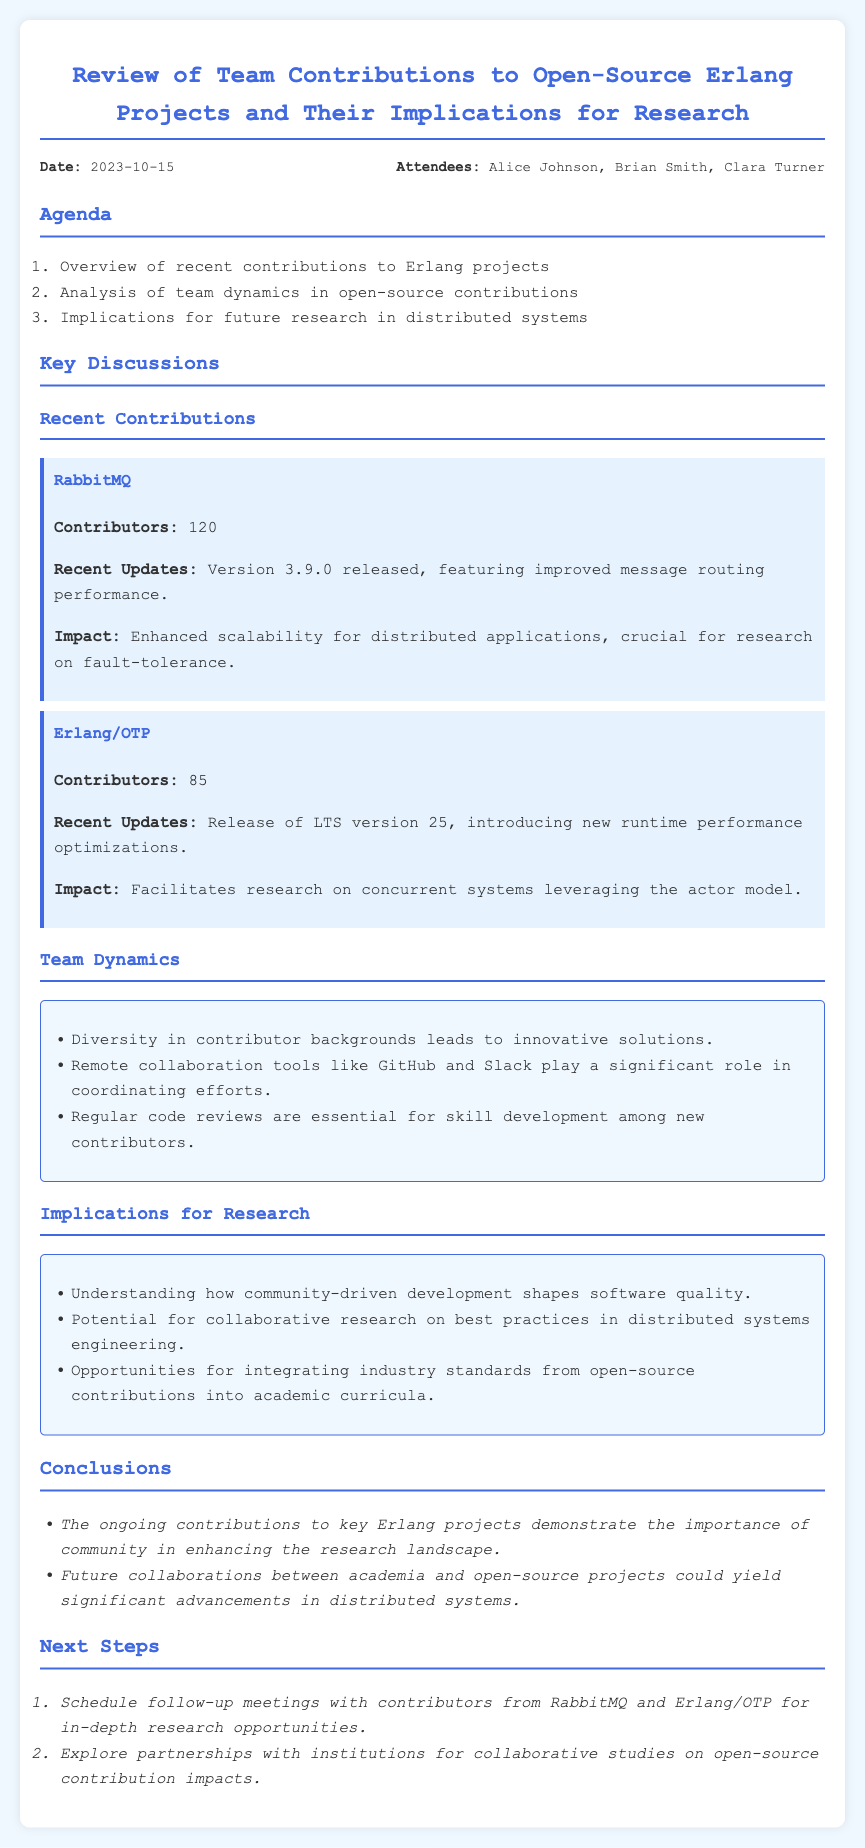What was the date of the meeting? The date of the meeting is stated in the document under the date-attendees section.
Answer: 2023-10-15 Who were the attendees of the meeting? The attendees are listed in the date-attendees section of the document.
Answer: Alice Johnson, Brian Smith, Clara Turner How many contributors are involved in RabbitMQ? The number of contributors is mentioned in the recent contributions section specifically for RabbitMQ.
Answer: 120 What is the recent update for Erlang/OTP? The recent update for Erlang/OTP is detailed in the recent contributions section.
Answer: Release of LTS version 25 What implications for research are mentioned regarding community-driven development? The implications for research are listed in the insights section regarding open-source contributions.
Answer: Shapes software quality What is one reason for the importance of diversity in contributor backgrounds? The findings provide reasoning regarding team dynamics and contributor backgrounds.
Answer: Innovative solutions What are the next steps mentioned for follow-up? The next steps are outlined in the next steps section of the document.
Answer: Schedule follow-up meetings What was a key discussion point about recent contributions? The key discussion point is highlighted in the recent contributions section of the document.
Answer: Enhanced scalability for distributed applications 